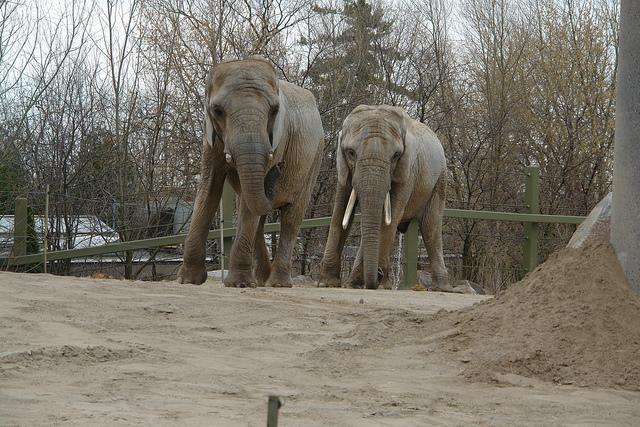How many elephants can you see?
Give a very brief answer. 2. 